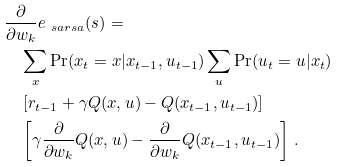Convert formula to latex. <formula><loc_0><loc_0><loc_500><loc_500>& \frac { \partial } { \partial w _ { k } } e _ { \ s a r s a } ( s ) = \\ & \quad \sum _ { x } \Pr ( x _ { t } = x | x _ { t - 1 } , u _ { t - 1 } ) \sum _ { u } \Pr ( u _ { t } = u | x _ { t } ) \\ & \quad \left [ r _ { t - 1 } + \gamma Q ( x , u ) - Q ( x _ { t - 1 } , u _ { t - 1 } ) \right ] \\ & \quad \left [ \gamma \frac { \partial } { \partial w _ { k } } Q ( x , u ) - \frac { \partial } { \partial w _ { k } } Q ( x _ { t - 1 } , u _ { t - 1 } ) \right ] \, .</formula> 